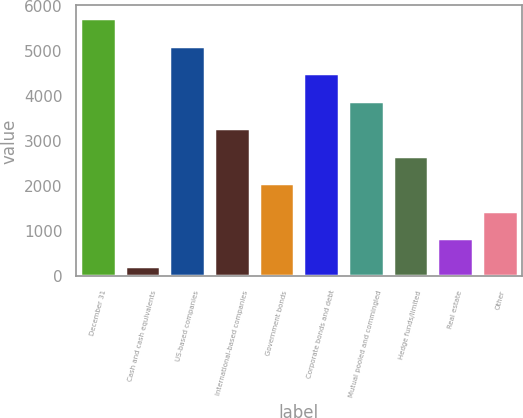Convert chart to OTSL. <chart><loc_0><loc_0><loc_500><loc_500><bar_chart><fcel>December 31<fcel>Cash and cash equivalents<fcel>US-based companies<fcel>International-based companies<fcel>Government bonds<fcel>Corporate bonds and debt<fcel>Mutual pooled and commingled<fcel>Hedge funds/limited<fcel>Real estate<fcel>Other<nl><fcel>5732.7<fcel>240<fcel>5122.4<fcel>3291.5<fcel>2070.9<fcel>4512.1<fcel>3901.8<fcel>2681.2<fcel>850.3<fcel>1460.6<nl></chart> 